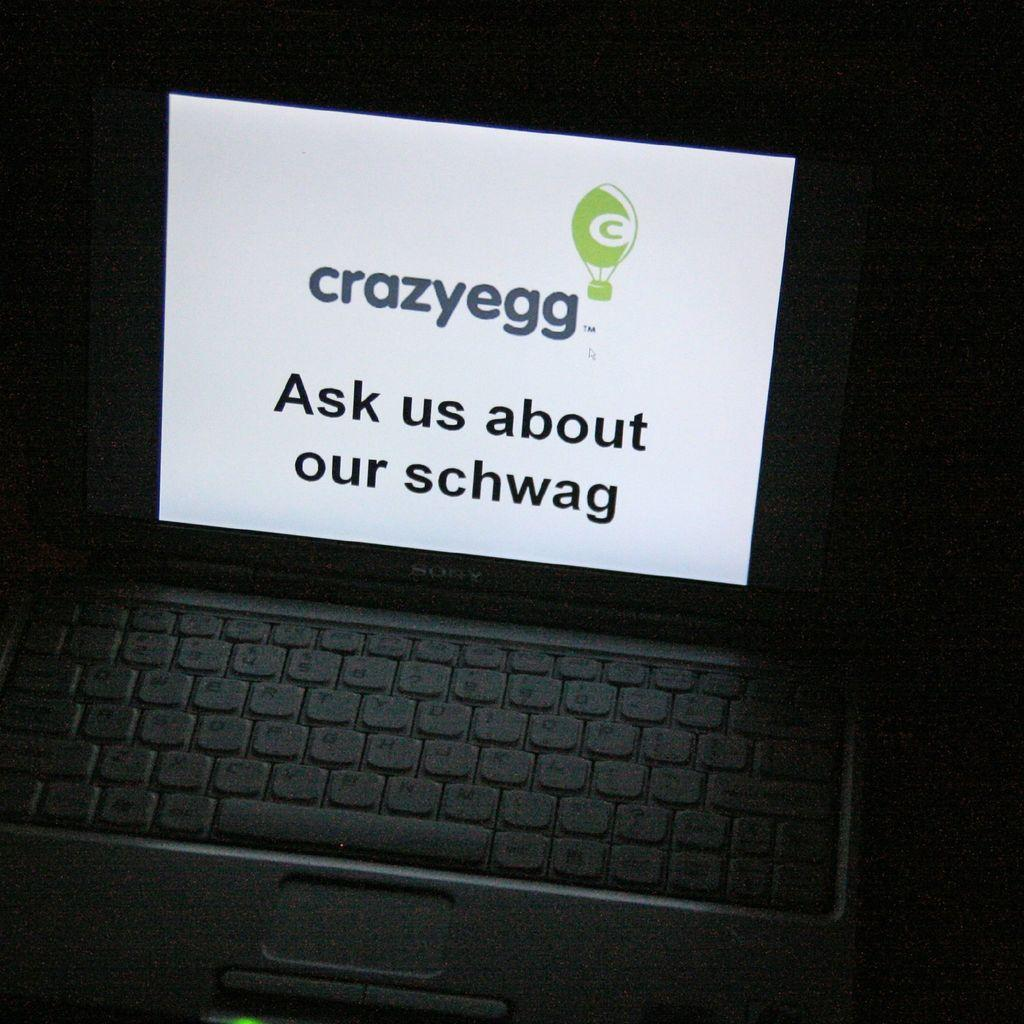<image>
Render a clear and concise summary of the photo. A laptop on display with a white paper that says Crazyegg. 